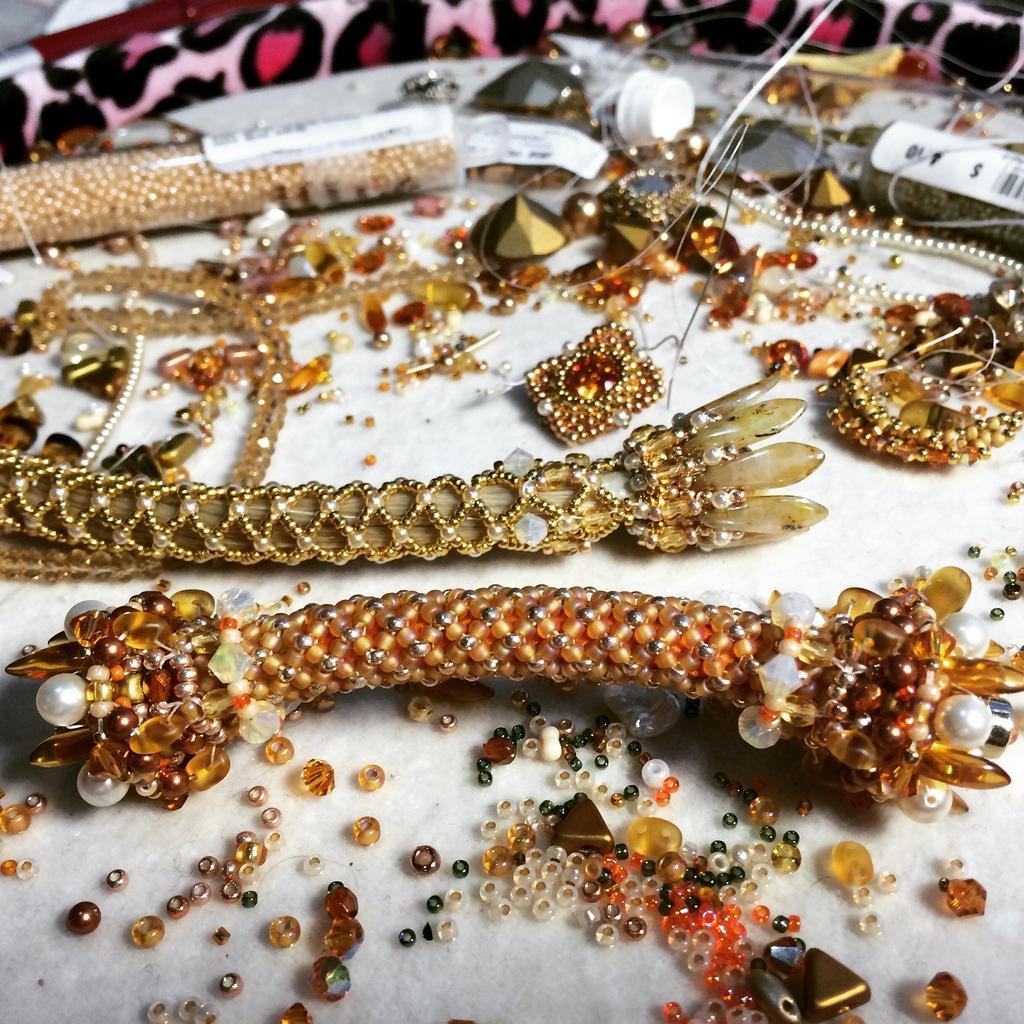Please provide a concise description of this image. In the center of the image we can see one white color object. On that object, we can see beads, stones, ornaments and a few other objects. At the top of the image, we can see one pink and black color object. 